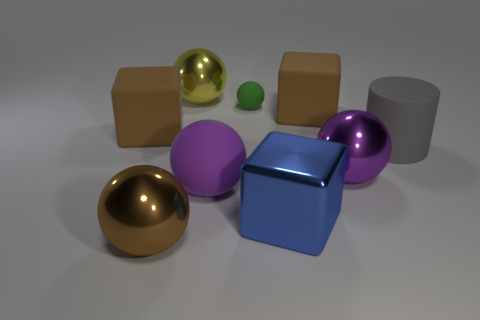Subtract all big purple balls. How many balls are left? 3 Subtract all yellow spheres. How many spheres are left? 4 Subtract all brown cubes. How many purple spheres are left? 2 Subtract all gray balls. Subtract all gray cylinders. How many balls are left? 5 Subtract all large purple cylinders. Subtract all blue metallic cubes. How many objects are left? 8 Add 5 green matte spheres. How many green matte spheres are left? 6 Add 9 large yellow balls. How many large yellow balls exist? 10 Subtract 1 yellow balls. How many objects are left? 8 Subtract all balls. How many objects are left? 4 Subtract 1 spheres. How many spheres are left? 4 